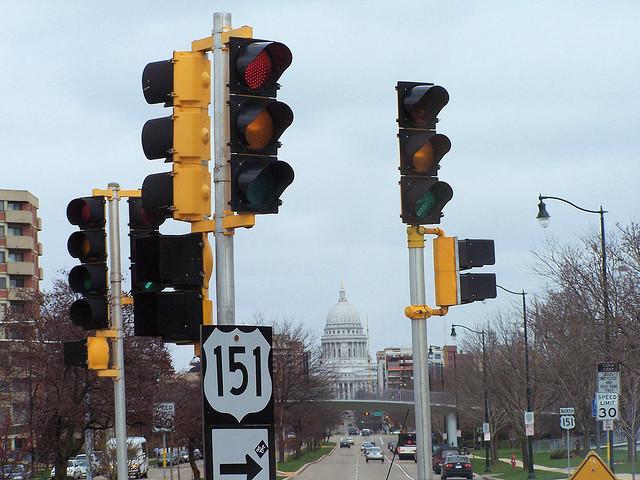What color are these traffic lights?
Keep it brief. Yellow. What number is on the sign?
Short answer required. 151. Is the white building the White House?
Keep it brief. Yes. 